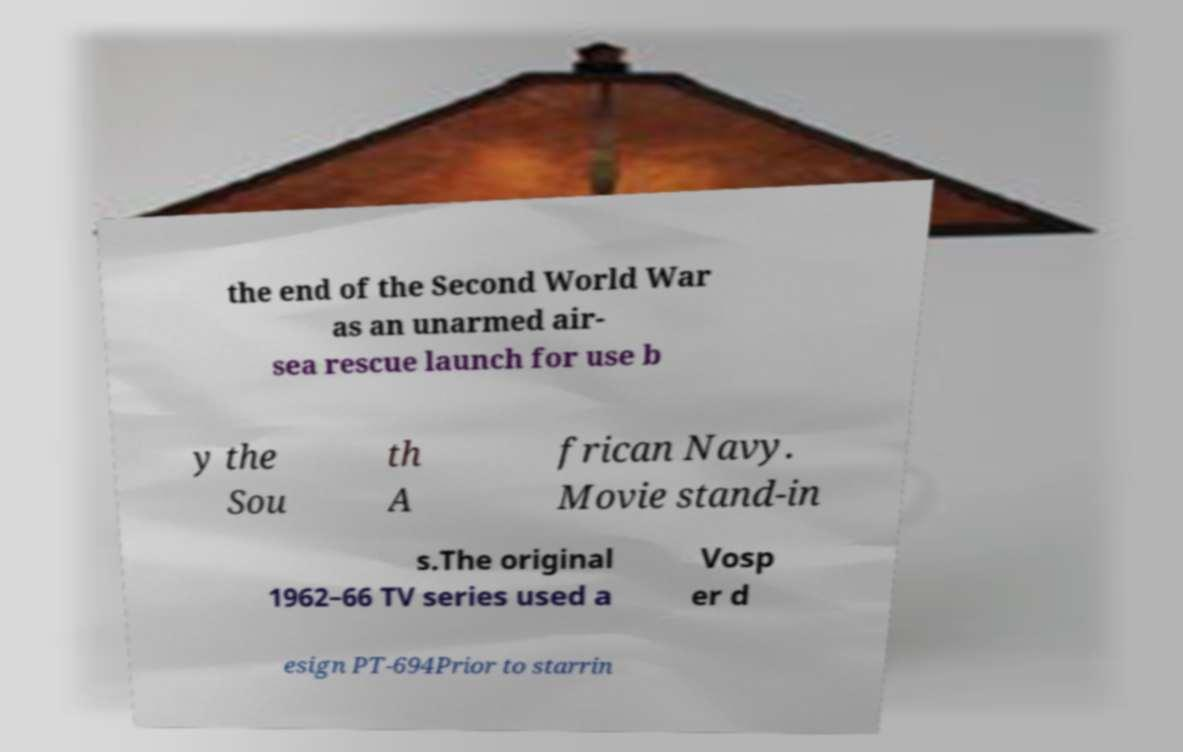I need the written content from this picture converted into text. Can you do that? the end of the Second World War as an unarmed air- sea rescue launch for use b y the Sou th A frican Navy. Movie stand-in s.The original 1962–66 TV series used a Vosp er d esign PT-694Prior to starrin 